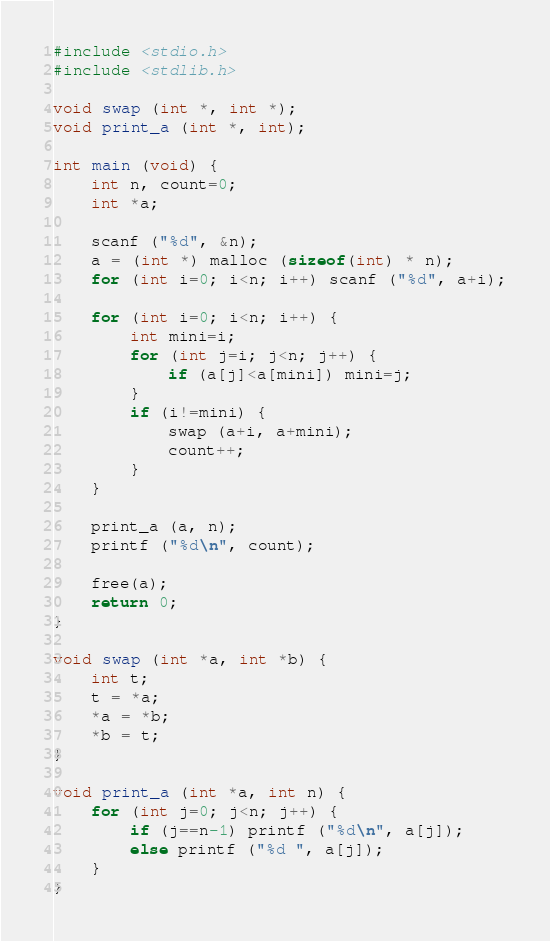<code> <loc_0><loc_0><loc_500><loc_500><_C_>#include <stdio.h>
#include <stdlib.h>

void swap (int *, int *);
void print_a (int *, int);

int main (void) {
    int n, count=0;
    int *a;

    scanf ("%d", &n);
    a = (int *) malloc (sizeof(int) * n);
    for (int i=0; i<n; i++) scanf ("%d", a+i);

    for (int i=0; i<n; i++) {
        int mini=i;
        for (int j=i; j<n; j++) {
            if (a[j]<a[mini]) mini=j;
        }
        if (i!=mini) {
            swap (a+i, a+mini);
            count++;
        }
    }

    print_a (a, n);
    printf ("%d\n", count);

    free(a);
    return 0;
}

void swap (int *a, int *b) {
    int t;
    t = *a;
    *a = *b;
    *b = t;
}

void print_a (int *a, int n) {
    for (int j=0; j<n; j++) {
        if (j==n-1) printf ("%d\n", a[j]);
        else printf ("%d ", a[j]);
    }
}
</code> 